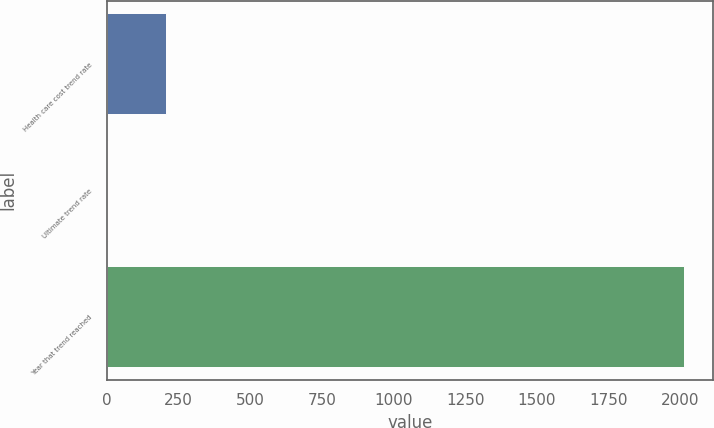Convert chart. <chart><loc_0><loc_0><loc_500><loc_500><bar_chart><fcel>Health care cost trend rate<fcel>Ultimate trend rate<fcel>Year that trend reached<nl><fcel>205.9<fcel>5<fcel>2014<nl></chart> 